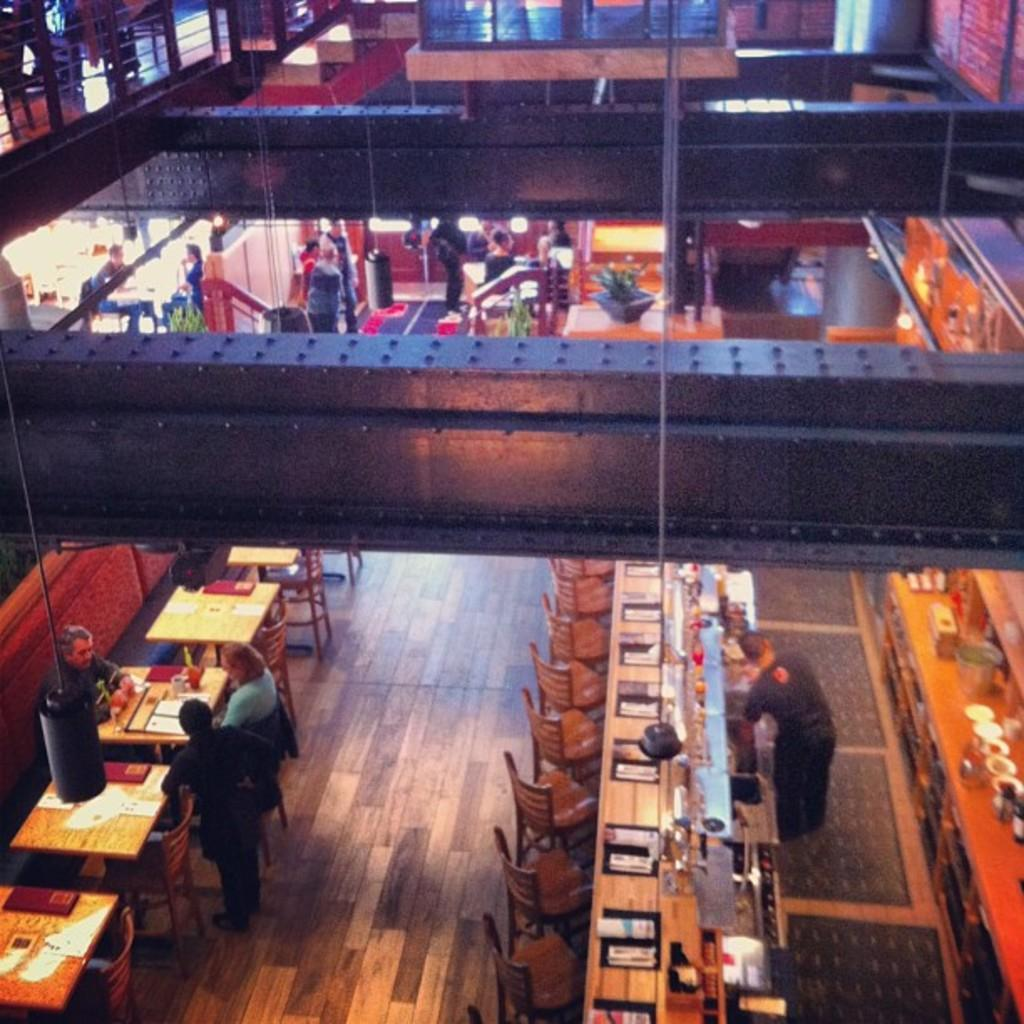What type of furniture is visible in the image? There are tables and chairs in the image. Are the tables and chairs being used by anyone? Some people are sitting on the tables and chairs. Are there any tables and chairs that are not being used? Some tables and chairs are left empty. What type of sea creatures can be seen swimming on the canvas in the image? There is no canvas or sea creatures present in the image. 